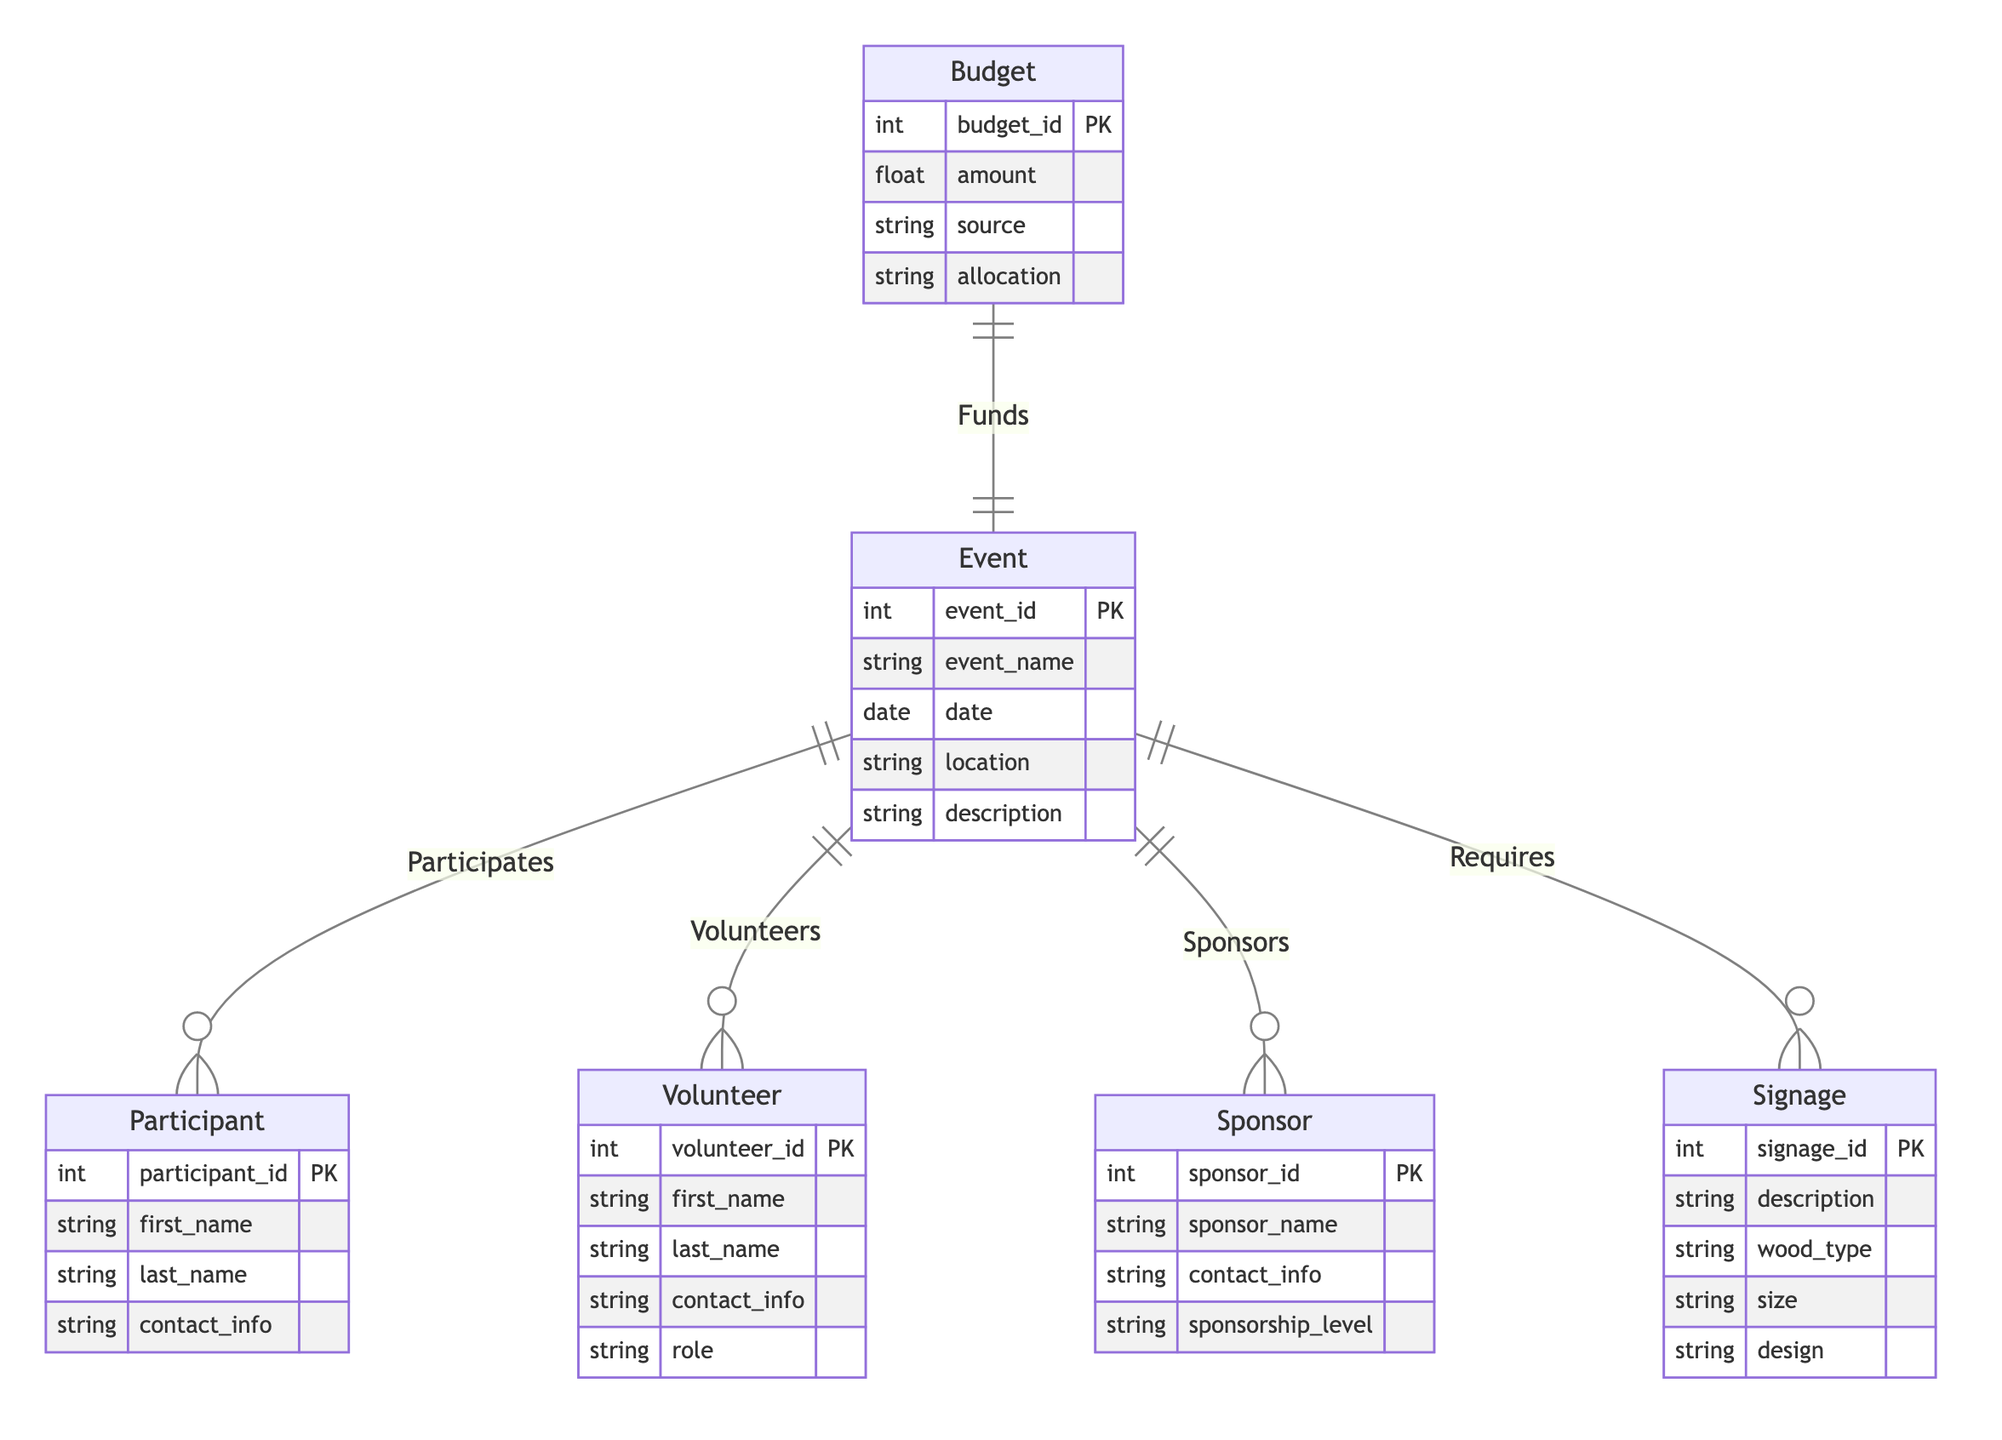What entities are involved in the event planning process? The diagram contains the following entities related to event planning: Event, Participant, Volunteer, Sponsor, Signage, and Budget.
Answer: Event, Participant, Volunteer, Sponsor, Signage, Budget How many relationships are defined in the diagram? Upon reviewing the connections between the entities, there are a total of five distinct relationships: Participates, Volunteers, Sponsors, Requires, and Funds.
Answer: Five Which entity is linked to Signage? The relationship labeled as "Requires" connects the Event entity with the Signage entity, indicating that an Event necessitates Signage.
Answer: Event What is the primary key attribute of the Sponsor entity? The diagram designates "sponsor_id" as the primary key for the Sponsor entity, indicated by PK notation next to it.
Answer: sponsor_id How many roles are listed for Volunteers? The Volunteer entity includes a specific attribute called "role," which refers to the different positions or responsibilities that volunteers can have. However, the diagram does not define a specific number of roles; it just identifies the presence of the "role" attribute.
Answer: One 